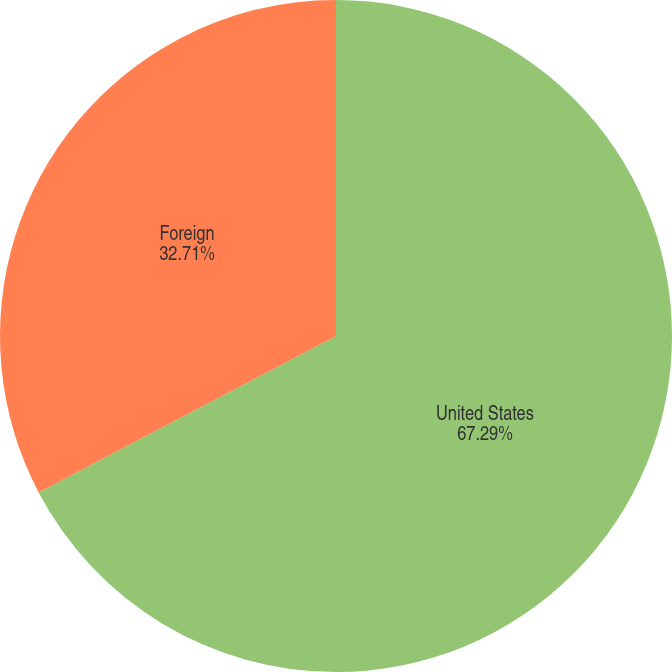Convert chart to OTSL. <chart><loc_0><loc_0><loc_500><loc_500><pie_chart><fcel>United States<fcel>Foreign<nl><fcel>67.29%<fcel>32.71%<nl></chart> 